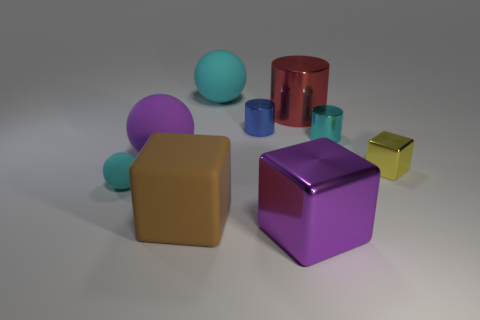There is a cyan object that is the same shape as the large red object; what size is it?
Your answer should be very brief. Small. What number of cylinders are right of the red metal object?
Offer a very short reply. 1. The tiny thing that is to the left of the cyan rubber sphere on the right side of the small matte sphere is what color?
Give a very brief answer. Cyan. Is the number of brown objects to the left of the brown rubber block the same as the number of tiny objects that are left of the tiny block?
Offer a terse response. No. What number of balls are either blue matte objects or metallic things?
Provide a short and direct response. 0. How many other things are made of the same material as the tiny ball?
Offer a terse response. 3. There is a cyan rubber object on the right side of the large matte cube; what is its shape?
Ensure brevity in your answer.  Sphere. There is a purple object that is behind the cyan rubber sphere that is in front of the yellow metallic thing; what is it made of?
Offer a terse response. Rubber. Is the number of metal cylinders right of the purple rubber thing greater than the number of blue objects?
Offer a very short reply. Yes. How many other things are there of the same color as the small sphere?
Your response must be concise. 2. 